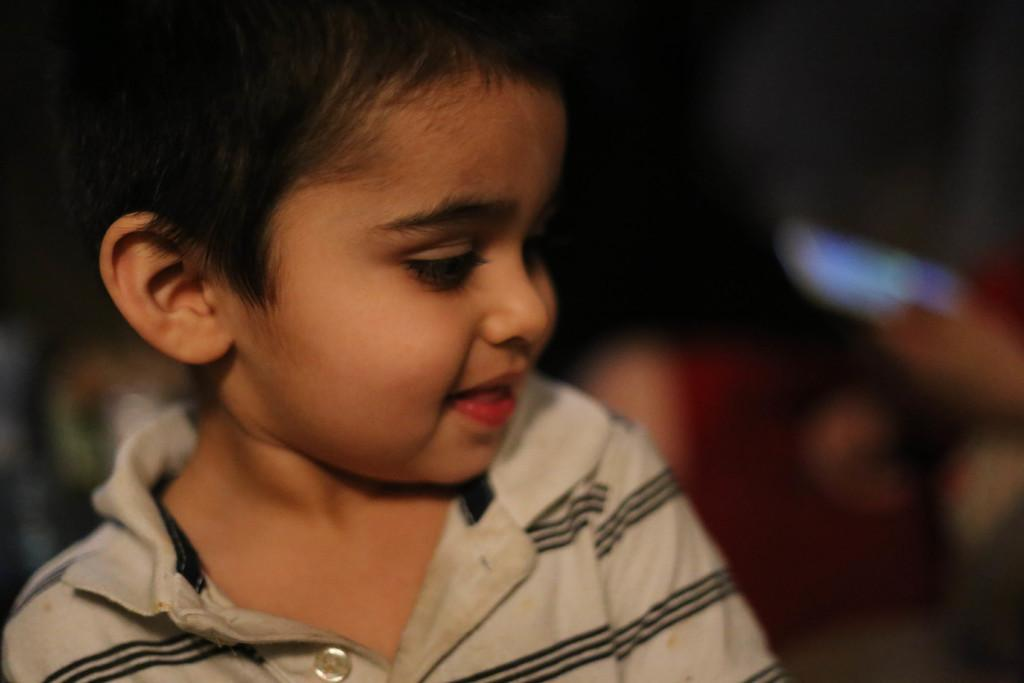What is the main subject of the image? There is a child in the image. Can you describe the background of the image? The background of the image is blurred. What type of goat can be seen interacting with the child in the image? There is no goat present in the image, and therefore no such interaction can be observed. 